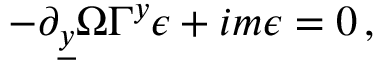<formula> <loc_0><loc_0><loc_500><loc_500>- \partial _ { \underline { y } } \Omega \Gamma ^ { y } \epsilon + i m \epsilon = 0 \, ,</formula> 